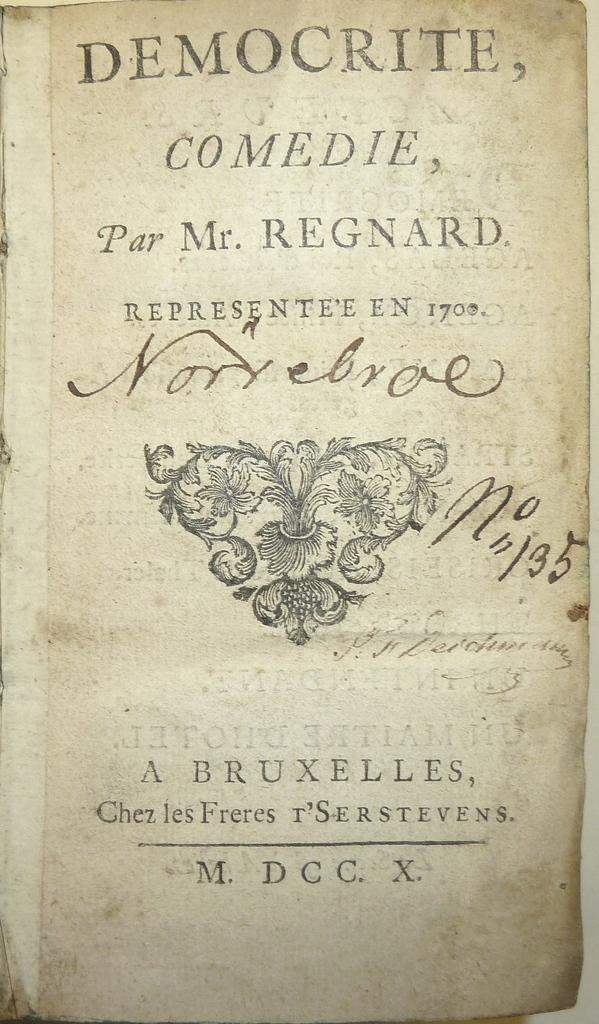<image>
Write a terse but informative summary of the picture. A tattered page has "Deomoctire, Comedie, Par Mr. Regnard." at the top. 